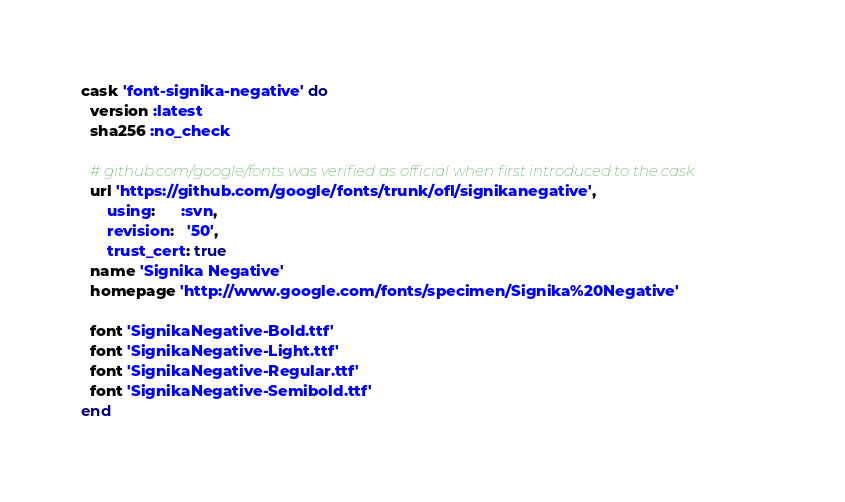Convert code to text. <code><loc_0><loc_0><loc_500><loc_500><_Ruby_>cask 'font-signika-negative' do
  version :latest
  sha256 :no_check

  # github.com/google/fonts was verified as official when first introduced to the cask
  url 'https://github.com/google/fonts/trunk/ofl/signikanegative',
      using:      :svn,
      revision:   '50',
      trust_cert: true
  name 'Signika Negative'
  homepage 'http://www.google.com/fonts/specimen/Signika%20Negative'

  font 'SignikaNegative-Bold.ttf'
  font 'SignikaNegative-Light.ttf'
  font 'SignikaNegative-Regular.ttf'
  font 'SignikaNegative-Semibold.ttf'
end
</code> 